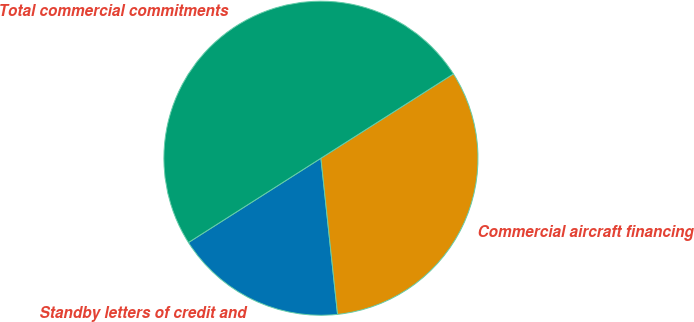<chart> <loc_0><loc_0><loc_500><loc_500><pie_chart><fcel>Standby letters of credit and<fcel>Commercial aircraft financing<fcel>Total commercial commitments<nl><fcel>17.67%<fcel>32.33%<fcel>50.0%<nl></chart> 